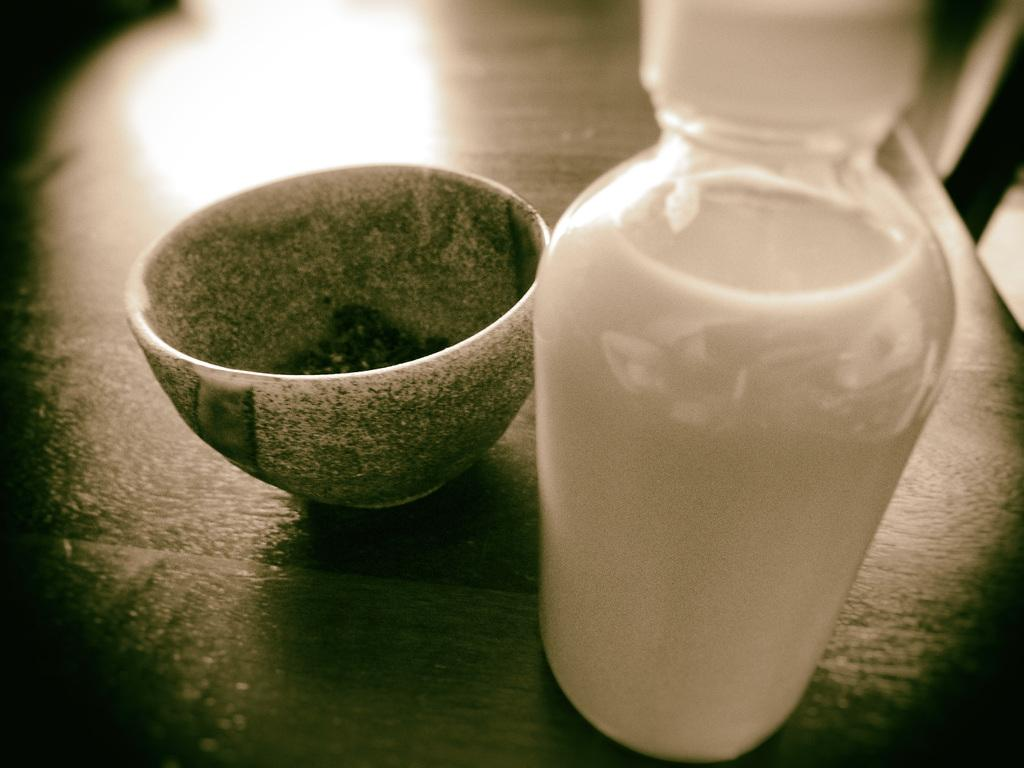What type of furniture is present in the image? There is a table in the image. What is the color of the table? The table is black. What is placed on the table? There is a bottle on the table. What is inside the bottle? The bottle contains a white liquid. What other object can be seen in the image? There is a bowl in the image. What is the color of the bowl? The bowl is green. What type of laborer is working with the plough in the image? There is no laborer or plough present in the image; it only features a black table, a bottle with a white liquid, and a green bowl. 